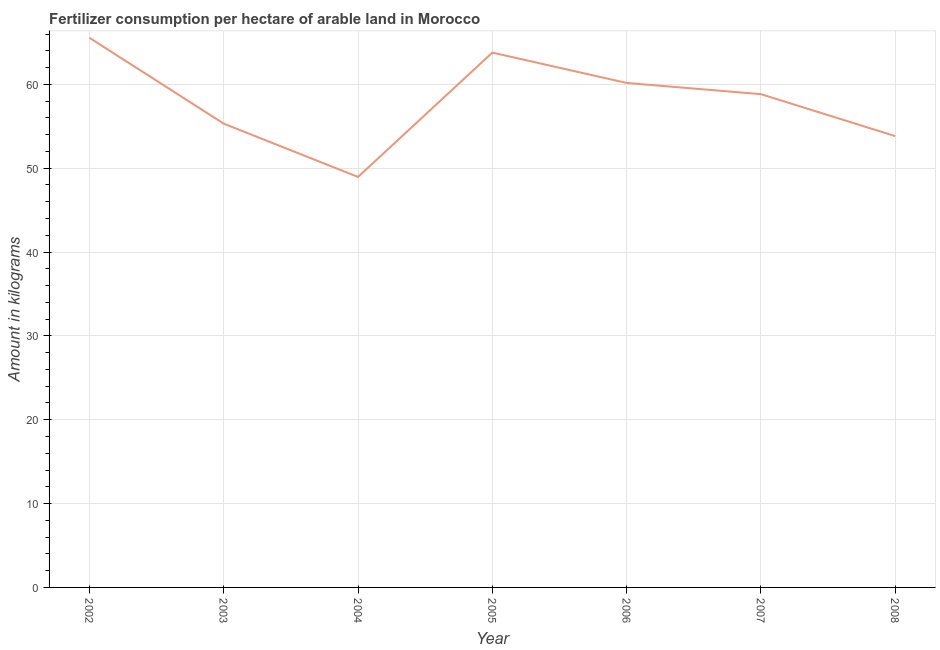What is the amount of fertilizer consumption in 2008?
Your answer should be compact. 53.83. Across all years, what is the maximum amount of fertilizer consumption?
Keep it short and to the point. 65.55. Across all years, what is the minimum amount of fertilizer consumption?
Provide a short and direct response. 48.96. In which year was the amount of fertilizer consumption minimum?
Make the answer very short. 2004. What is the sum of the amount of fertilizer consumption?
Keep it short and to the point. 406.44. What is the difference between the amount of fertilizer consumption in 2002 and 2004?
Ensure brevity in your answer.  16.6. What is the average amount of fertilizer consumption per year?
Keep it short and to the point. 58.06. What is the median amount of fertilizer consumption?
Offer a terse response. 58.83. Do a majority of the years between 2006 and 2005 (inclusive) have amount of fertilizer consumption greater than 60 kg?
Ensure brevity in your answer.  No. What is the ratio of the amount of fertilizer consumption in 2003 to that in 2008?
Your answer should be very brief. 1.03. Is the amount of fertilizer consumption in 2003 less than that in 2005?
Keep it short and to the point. Yes. What is the difference between the highest and the second highest amount of fertilizer consumption?
Provide a succinct answer. 1.77. What is the difference between the highest and the lowest amount of fertilizer consumption?
Provide a short and direct response. 16.6. How many lines are there?
Keep it short and to the point. 1. What is the difference between two consecutive major ticks on the Y-axis?
Offer a terse response. 10. Are the values on the major ticks of Y-axis written in scientific E-notation?
Give a very brief answer. No. Does the graph contain any zero values?
Your response must be concise. No. Does the graph contain grids?
Give a very brief answer. Yes. What is the title of the graph?
Keep it short and to the point. Fertilizer consumption per hectare of arable land in Morocco . What is the label or title of the X-axis?
Provide a short and direct response. Year. What is the label or title of the Y-axis?
Provide a short and direct response. Amount in kilograms. What is the Amount in kilograms of 2002?
Provide a succinct answer. 65.55. What is the Amount in kilograms in 2003?
Offer a terse response. 55.31. What is the Amount in kilograms in 2004?
Your answer should be compact. 48.96. What is the Amount in kilograms of 2005?
Keep it short and to the point. 63.79. What is the Amount in kilograms of 2006?
Provide a succinct answer. 60.17. What is the Amount in kilograms of 2007?
Provide a succinct answer. 58.83. What is the Amount in kilograms in 2008?
Make the answer very short. 53.83. What is the difference between the Amount in kilograms in 2002 and 2003?
Provide a succinct answer. 10.24. What is the difference between the Amount in kilograms in 2002 and 2004?
Give a very brief answer. 16.6. What is the difference between the Amount in kilograms in 2002 and 2005?
Give a very brief answer. 1.77. What is the difference between the Amount in kilograms in 2002 and 2006?
Keep it short and to the point. 5.39. What is the difference between the Amount in kilograms in 2002 and 2007?
Ensure brevity in your answer.  6.72. What is the difference between the Amount in kilograms in 2002 and 2008?
Offer a terse response. 11.73. What is the difference between the Amount in kilograms in 2003 and 2004?
Give a very brief answer. 6.35. What is the difference between the Amount in kilograms in 2003 and 2005?
Offer a terse response. -8.48. What is the difference between the Amount in kilograms in 2003 and 2006?
Offer a very short reply. -4.86. What is the difference between the Amount in kilograms in 2003 and 2007?
Your answer should be compact. -3.52. What is the difference between the Amount in kilograms in 2003 and 2008?
Give a very brief answer. 1.48. What is the difference between the Amount in kilograms in 2004 and 2005?
Provide a short and direct response. -14.83. What is the difference between the Amount in kilograms in 2004 and 2006?
Ensure brevity in your answer.  -11.21. What is the difference between the Amount in kilograms in 2004 and 2007?
Provide a short and direct response. -9.87. What is the difference between the Amount in kilograms in 2004 and 2008?
Keep it short and to the point. -4.87. What is the difference between the Amount in kilograms in 2005 and 2006?
Your answer should be compact. 3.62. What is the difference between the Amount in kilograms in 2005 and 2007?
Make the answer very short. 4.96. What is the difference between the Amount in kilograms in 2005 and 2008?
Your response must be concise. 9.96. What is the difference between the Amount in kilograms in 2006 and 2007?
Your answer should be very brief. 1.34. What is the difference between the Amount in kilograms in 2006 and 2008?
Offer a terse response. 6.34. What is the difference between the Amount in kilograms in 2007 and 2008?
Provide a succinct answer. 5. What is the ratio of the Amount in kilograms in 2002 to that in 2003?
Keep it short and to the point. 1.19. What is the ratio of the Amount in kilograms in 2002 to that in 2004?
Keep it short and to the point. 1.34. What is the ratio of the Amount in kilograms in 2002 to that in 2005?
Provide a succinct answer. 1.03. What is the ratio of the Amount in kilograms in 2002 to that in 2006?
Your answer should be compact. 1.09. What is the ratio of the Amount in kilograms in 2002 to that in 2007?
Offer a terse response. 1.11. What is the ratio of the Amount in kilograms in 2002 to that in 2008?
Offer a very short reply. 1.22. What is the ratio of the Amount in kilograms in 2003 to that in 2004?
Keep it short and to the point. 1.13. What is the ratio of the Amount in kilograms in 2003 to that in 2005?
Your response must be concise. 0.87. What is the ratio of the Amount in kilograms in 2003 to that in 2006?
Give a very brief answer. 0.92. What is the ratio of the Amount in kilograms in 2003 to that in 2008?
Make the answer very short. 1.03. What is the ratio of the Amount in kilograms in 2004 to that in 2005?
Offer a very short reply. 0.77. What is the ratio of the Amount in kilograms in 2004 to that in 2006?
Your answer should be compact. 0.81. What is the ratio of the Amount in kilograms in 2004 to that in 2007?
Ensure brevity in your answer.  0.83. What is the ratio of the Amount in kilograms in 2004 to that in 2008?
Offer a terse response. 0.91. What is the ratio of the Amount in kilograms in 2005 to that in 2006?
Your answer should be very brief. 1.06. What is the ratio of the Amount in kilograms in 2005 to that in 2007?
Your answer should be very brief. 1.08. What is the ratio of the Amount in kilograms in 2005 to that in 2008?
Make the answer very short. 1.19. What is the ratio of the Amount in kilograms in 2006 to that in 2008?
Keep it short and to the point. 1.12. What is the ratio of the Amount in kilograms in 2007 to that in 2008?
Offer a terse response. 1.09. 